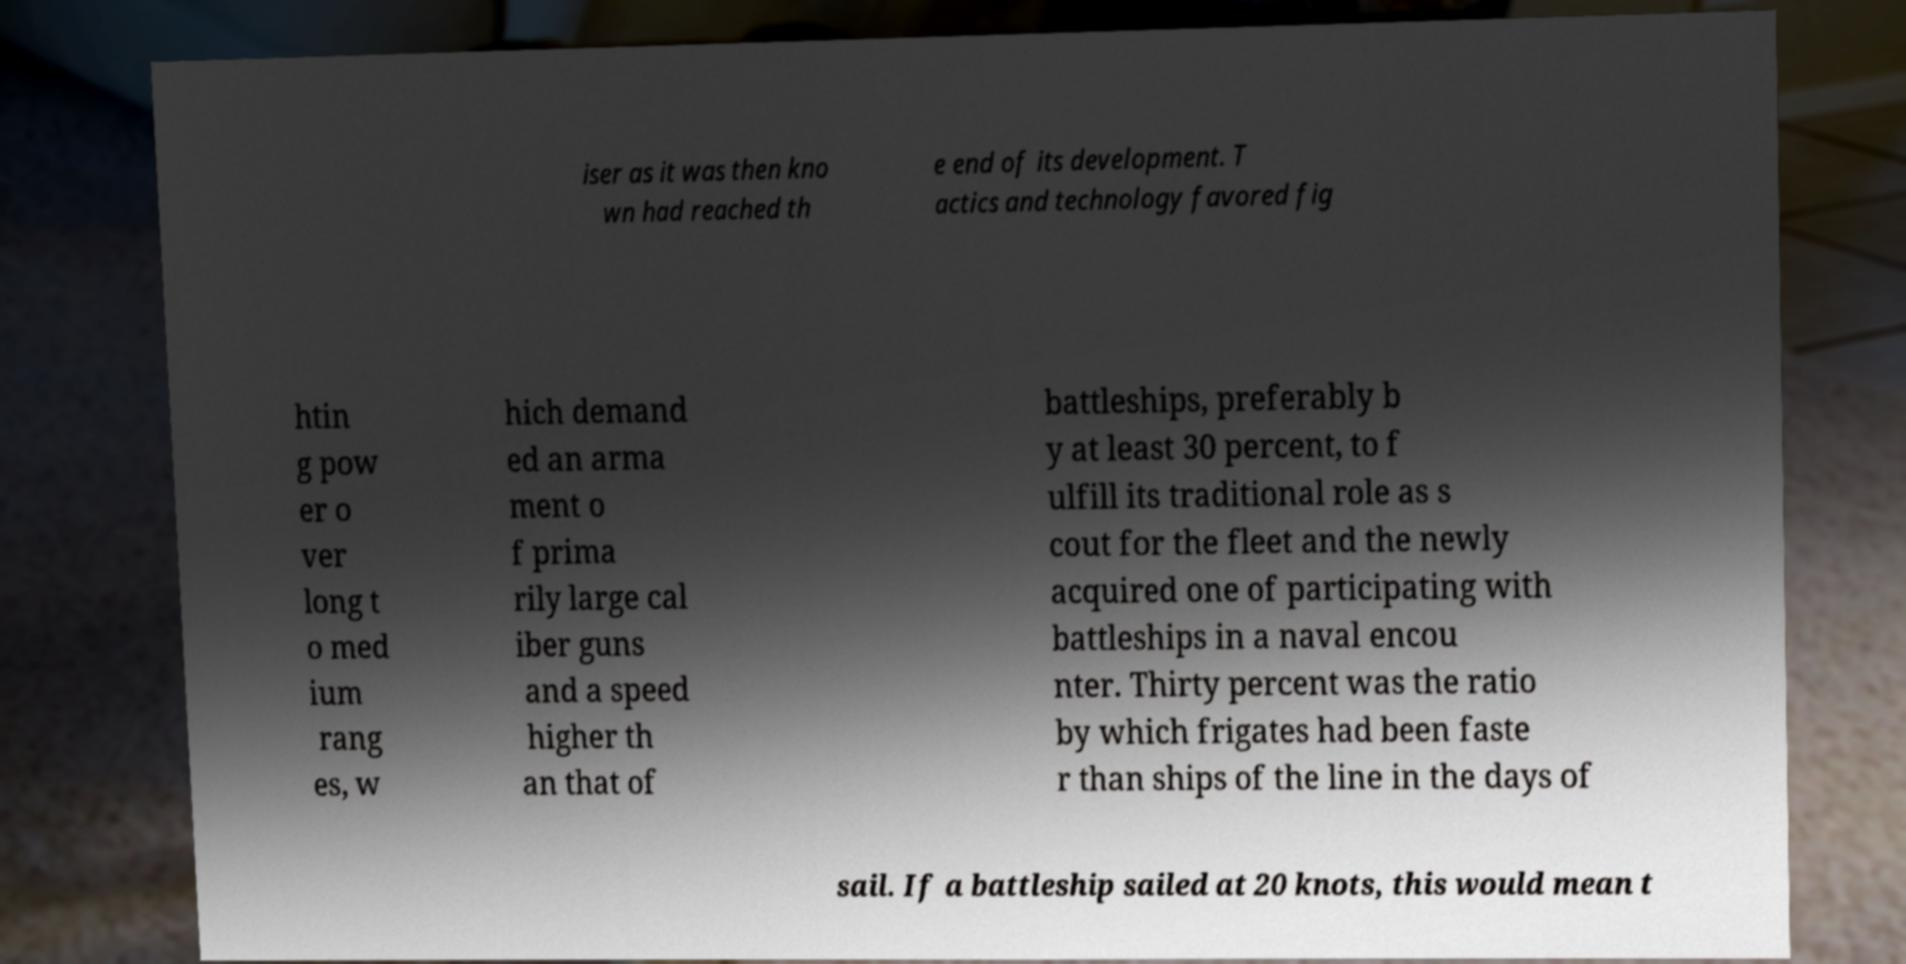I need the written content from this picture converted into text. Can you do that? iser as it was then kno wn had reached th e end of its development. T actics and technology favored fig htin g pow er o ver long t o med ium rang es, w hich demand ed an arma ment o f prima rily large cal iber guns and a speed higher th an that of battleships, preferably b y at least 30 percent, to f ulfill its traditional role as s cout for the fleet and the newly acquired one of participating with battleships in a naval encou nter. Thirty percent was the ratio by which frigates had been faste r than ships of the line in the days of sail. If a battleship sailed at 20 knots, this would mean t 